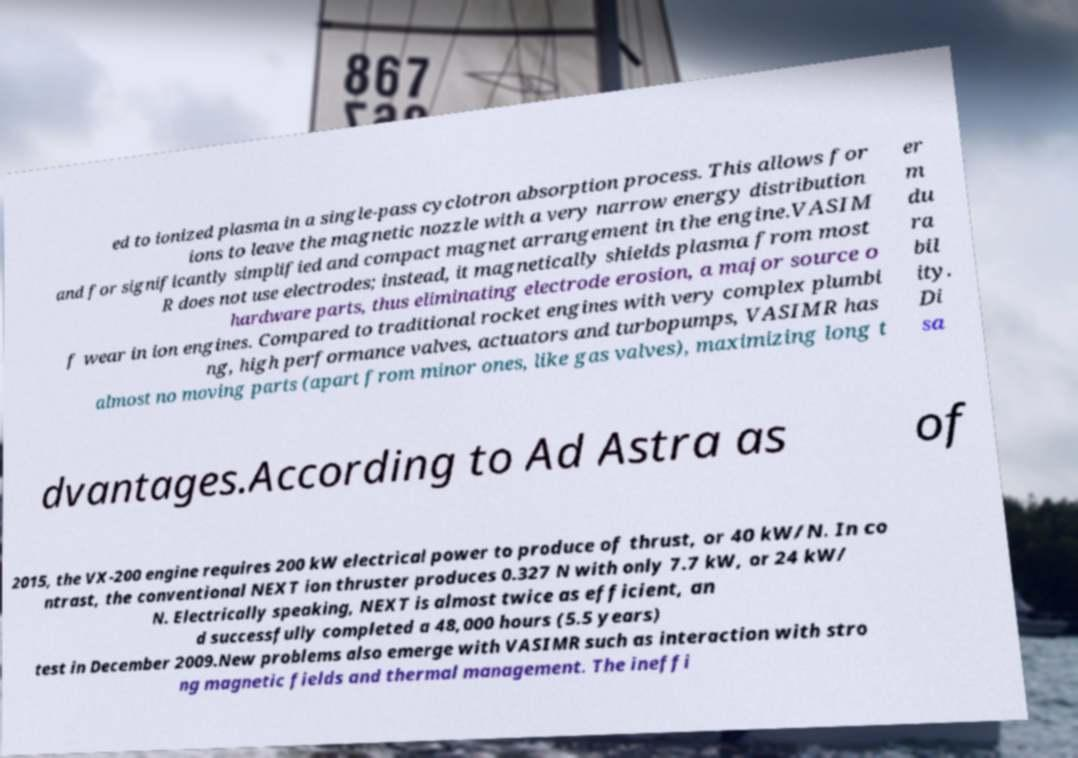Please read and relay the text visible in this image. What does it say? ed to ionized plasma in a single-pass cyclotron absorption process. This allows for ions to leave the magnetic nozzle with a very narrow energy distribution and for significantly simplified and compact magnet arrangement in the engine.VASIM R does not use electrodes; instead, it magnetically shields plasma from most hardware parts, thus eliminating electrode erosion, a major source o f wear in ion engines. Compared to traditional rocket engines with very complex plumbi ng, high performance valves, actuators and turbopumps, VASIMR has almost no moving parts (apart from minor ones, like gas valves), maximizing long t er m du ra bil ity. Di sa dvantages.According to Ad Astra as of 2015, the VX-200 engine requires 200 kW electrical power to produce of thrust, or 40 kW/N. In co ntrast, the conventional NEXT ion thruster produces 0.327 N with only 7.7 kW, or 24 kW/ N. Electrically speaking, NEXT is almost twice as efficient, an d successfully completed a 48,000 hours (5.5 years) test in December 2009.New problems also emerge with VASIMR such as interaction with stro ng magnetic fields and thermal management. The ineffi 